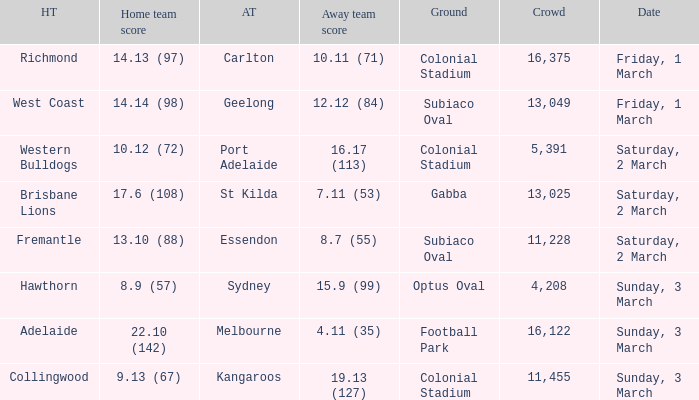Where did the away team essendon have their home base? Subiaco Oval. Could you parse the entire table as a dict? {'header': ['HT', 'Home team score', 'AT', 'Away team score', 'Ground', 'Crowd', 'Date'], 'rows': [['Richmond', '14.13 (97)', 'Carlton', '10.11 (71)', 'Colonial Stadium', '16,375', 'Friday, 1 March'], ['West Coast', '14.14 (98)', 'Geelong', '12.12 (84)', 'Subiaco Oval', '13,049', 'Friday, 1 March'], ['Western Bulldogs', '10.12 (72)', 'Port Adelaide', '16.17 (113)', 'Colonial Stadium', '5,391', 'Saturday, 2 March'], ['Brisbane Lions', '17.6 (108)', 'St Kilda', '7.11 (53)', 'Gabba', '13,025', 'Saturday, 2 March'], ['Fremantle', '13.10 (88)', 'Essendon', '8.7 (55)', 'Subiaco Oval', '11,228', 'Saturday, 2 March'], ['Hawthorn', '8.9 (57)', 'Sydney', '15.9 (99)', 'Optus Oval', '4,208', 'Sunday, 3 March'], ['Adelaide', '22.10 (142)', 'Melbourne', '4.11 (35)', 'Football Park', '16,122', 'Sunday, 3 March'], ['Collingwood', '9.13 (67)', 'Kangaroos', '19.13 (127)', 'Colonial Stadium', '11,455', 'Sunday, 3 March']]} 